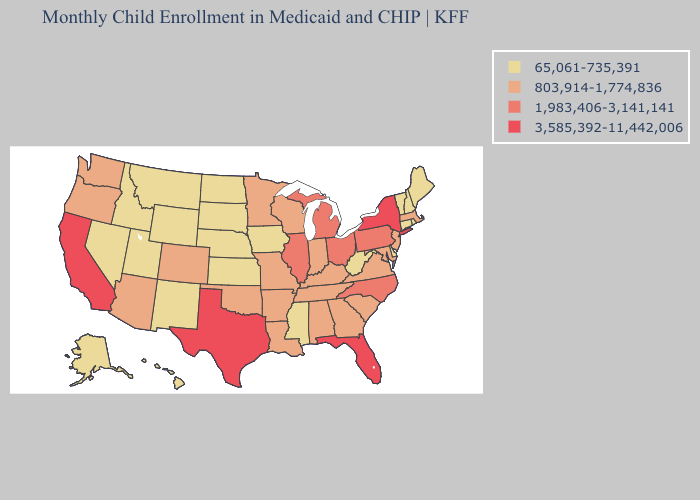Which states hav the highest value in the South?
Concise answer only. Florida, Texas. What is the lowest value in the USA?
Concise answer only. 65,061-735,391. Name the states that have a value in the range 803,914-1,774,836?
Short answer required. Alabama, Arizona, Arkansas, Colorado, Georgia, Indiana, Kentucky, Louisiana, Maryland, Massachusetts, Minnesota, Missouri, New Jersey, Oklahoma, Oregon, South Carolina, Tennessee, Virginia, Washington, Wisconsin. Among the states that border Texas , which have the lowest value?
Answer briefly. New Mexico. Name the states that have a value in the range 65,061-735,391?
Give a very brief answer. Alaska, Connecticut, Delaware, Hawaii, Idaho, Iowa, Kansas, Maine, Mississippi, Montana, Nebraska, Nevada, New Hampshire, New Mexico, North Dakota, Rhode Island, South Dakota, Utah, Vermont, West Virginia, Wyoming. Name the states that have a value in the range 803,914-1,774,836?
Keep it brief. Alabama, Arizona, Arkansas, Colorado, Georgia, Indiana, Kentucky, Louisiana, Maryland, Massachusetts, Minnesota, Missouri, New Jersey, Oklahoma, Oregon, South Carolina, Tennessee, Virginia, Washington, Wisconsin. What is the value of Minnesota?
Be succinct. 803,914-1,774,836. Does New Jersey have the highest value in the Northeast?
Write a very short answer. No. What is the lowest value in the USA?
Be succinct. 65,061-735,391. What is the value of Iowa?
Answer briefly. 65,061-735,391. Does New Mexico have the lowest value in the West?
Be succinct. Yes. Name the states that have a value in the range 65,061-735,391?
Write a very short answer. Alaska, Connecticut, Delaware, Hawaii, Idaho, Iowa, Kansas, Maine, Mississippi, Montana, Nebraska, Nevada, New Hampshire, New Mexico, North Dakota, Rhode Island, South Dakota, Utah, Vermont, West Virginia, Wyoming. Does the first symbol in the legend represent the smallest category?
Answer briefly. Yes. What is the value of Kansas?
Concise answer only. 65,061-735,391. Which states have the lowest value in the USA?
Short answer required. Alaska, Connecticut, Delaware, Hawaii, Idaho, Iowa, Kansas, Maine, Mississippi, Montana, Nebraska, Nevada, New Hampshire, New Mexico, North Dakota, Rhode Island, South Dakota, Utah, Vermont, West Virginia, Wyoming. 